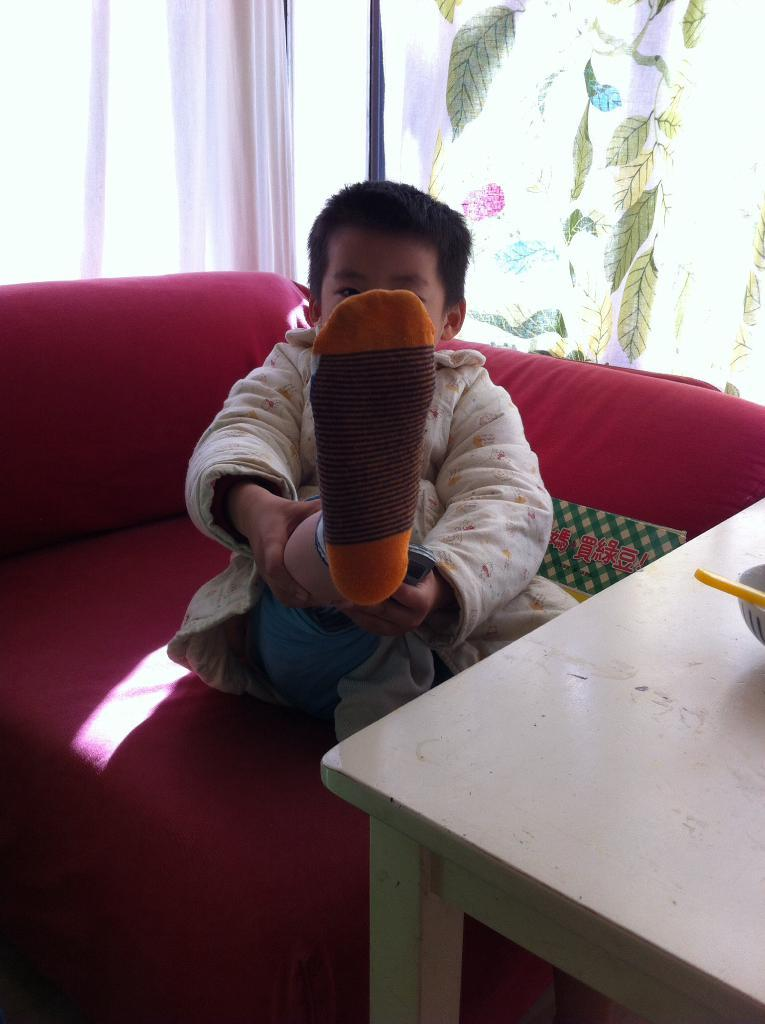What is the main subject of the image? The main subject of the image is a boy. What is the boy doing in the image? The boy is raising his right leg with his hands. What type of chain can be seen around the boy's neck in the image? There is no chain visible around the boy's neck in the image. What is the boy's digestive system like in the image? The image does not provide any information about the boy's digestive system. 